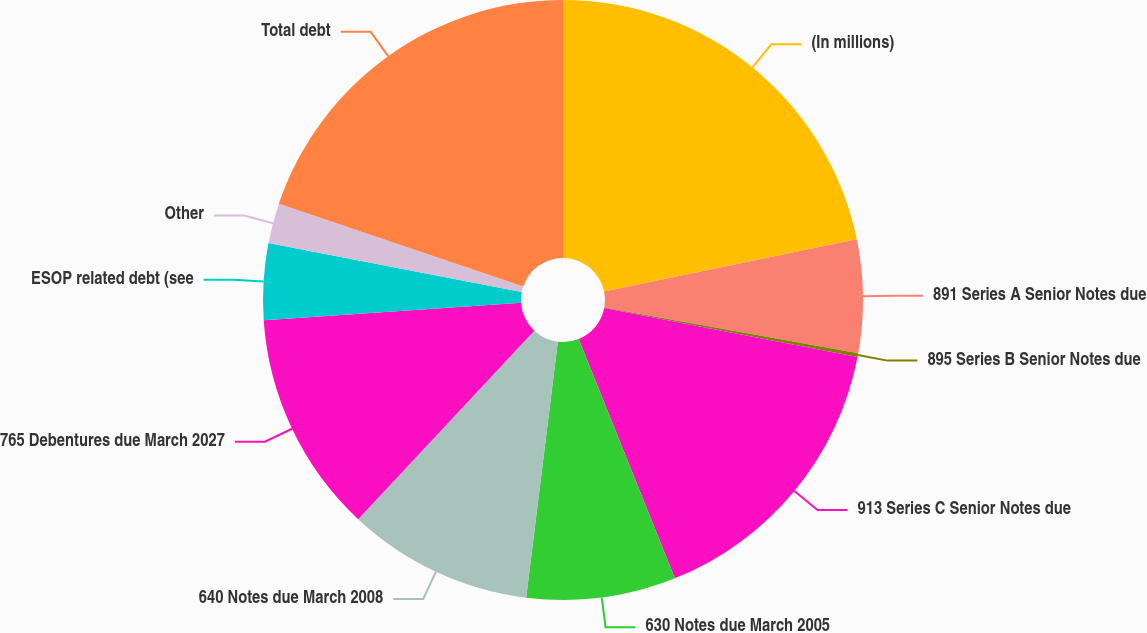<chart> <loc_0><loc_0><loc_500><loc_500><pie_chart><fcel>(In millions)<fcel>891 Series A Senior Notes due<fcel>895 Series B Senior Notes due<fcel>913 Series C Senior Notes due<fcel>630 Notes due March 2005<fcel>640 Notes due March 2008<fcel>765 Debentures due March 2027<fcel>ESOP related debt (see<fcel>Other<fcel>Total debt<nl><fcel>21.76%<fcel>6.08%<fcel>0.2%<fcel>15.88%<fcel>8.04%<fcel>10.0%<fcel>11.96%<fcel>4.12%<fcel>2.16%<fcel>19.8%<nl></chart> 